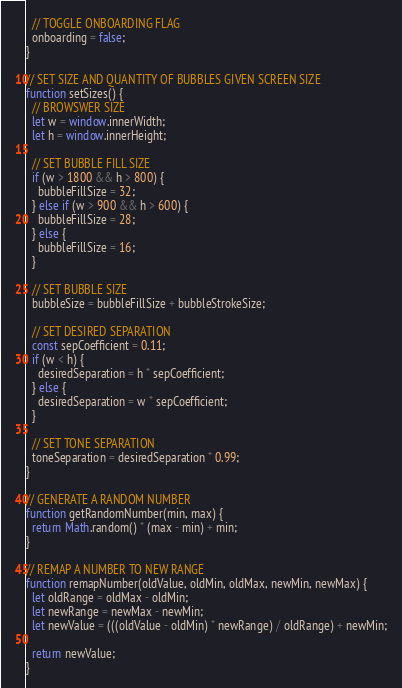<code> <loc_0><loc_0><loc_500><loc_500><_JavaScript_>  // TOGGLE ONBOARDING FLAG
  onboarding = false;
}

// SET SIZE AND QUANTITY OF BUBBLES GIVEN SCREEN SIZE
function setSizes() {
  // BROWSWER SIZE
  let w = window.innerWidth;
  let h = window.innerHeight;

  // SET BUBBLE FILL SIZE
  if (w > 1800 && h > 800) {
    bubbleFillSize = 32;
  } else if (w > 900 && h > 600) {
    bubbleFillSize = 28;
  } else {
    bubbleFillSize = 16;
  }

  // SET BUBBLE SIZE
  bubbleSize = bubbleFillSize + bubbleStrokeSize;

  // SET DESIRED SEPARATION
  const sepCoefficient = 0.11;
  if (w < h) {
    desiredSeparation = h * sepCoefficient;
  } else {
    desiredSeparation = w * sepCoefficient;
  }

  // SET TONE SEPARATION
  toneSeparation = desiredSeparation * 0.99;
}

// GENERATE A RANDOM NUMBER
function getRandomNumber(min, max) {
  return Math.random() * (max - min) + min;
}

// REMAP A NUMBER TO NEW RANGE
function remapNumber(oldValue, oldMin, oldMax, newMin, newMax) {
  let oldRange = oldMax - oldMin;
  let newRange = newMax - newMin;
  let newValue = (((oldValue - oldMin) * newRange) / oldRange) + newMin;

  return newValue;
}
</code> 